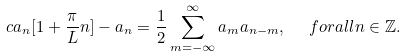Convert formula to latex. <formula><loc_0><loc_0><loc_500><loc_500>c a _ { n } [ 1 + { \frac { \pi } { L } } n ] - a _ { n } = \frac { 1 } { 2 } \sum _ { m = - \infty } ^ { \infty } a _ { m } a _ { n - m } , \ \ \ f o r a l l n \in \mathbb { Z } .</formula> 